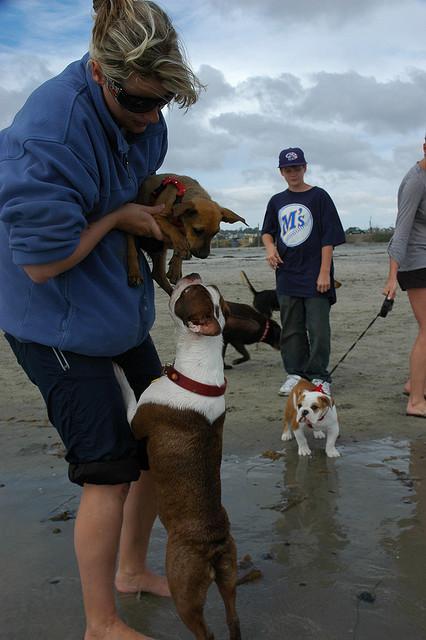What is the woman holding?
Quick response, please. Dog. What is in this animals mouth?
Write a very short answer. Nothing. Where is the dog?
Answer briefly. Beach. Do you think it is going to storm?
Answer briefly. Yes. What color are the dogs?
Concise answer only. Brown and white. Is the dog afraid?
Answer briefly. No. Is this a sporting dog?
Be succinct. No. Is the dog wearing two collars?
Be succinct. No. What is this dog anticipating?
Be succinct. Other dog. Is he dirty?
Write a very short answer. No. Are there any women in the picture?
Short answer required. Yes. How many dogs do you see?
Be succinct. 5. What color is the dog's collar?
Give a very brief answer. Red. What is the cat's attention on?
Answer briefly. No cat. Is this a color photo?
Give a very brief answer. Yes. How many dogs are running on the beach?
Give a very brief answer. 2. Is the man the owner of the dog?
Answer briefly. Yes. Are all the people barefooted?
Give a very brief answer. No. 